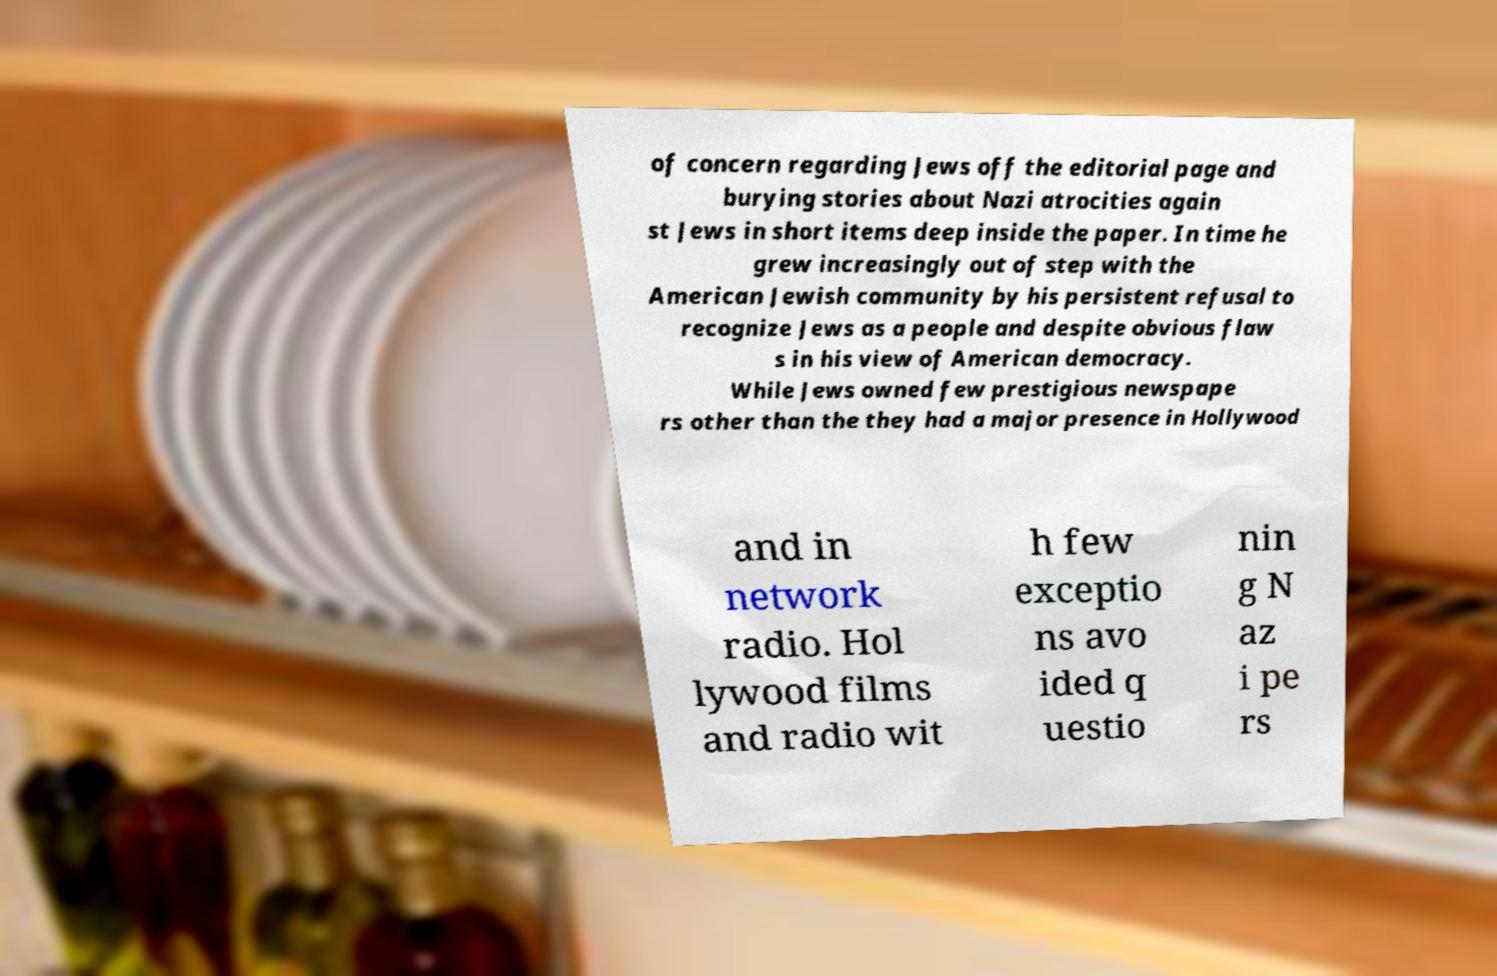Can you accurately transcribe the text from the provided image for me? of concern regarding Jews off the editorial page and burying stories about Nazi atrocities again st Jews in short items deep inside the paper. In time he grew increasingly out of step with the American Jewish community by his persistent refusal to recognize Jews as a people and despite obvious flaw s in his view of American democracy. While Jews owned few prestigious newspape rs other than the they had a major presence in Hollywood and in network radio. Hol lywood films and radio wit h few exceptio ns avo ided q uestio nin g N az i pe rs 